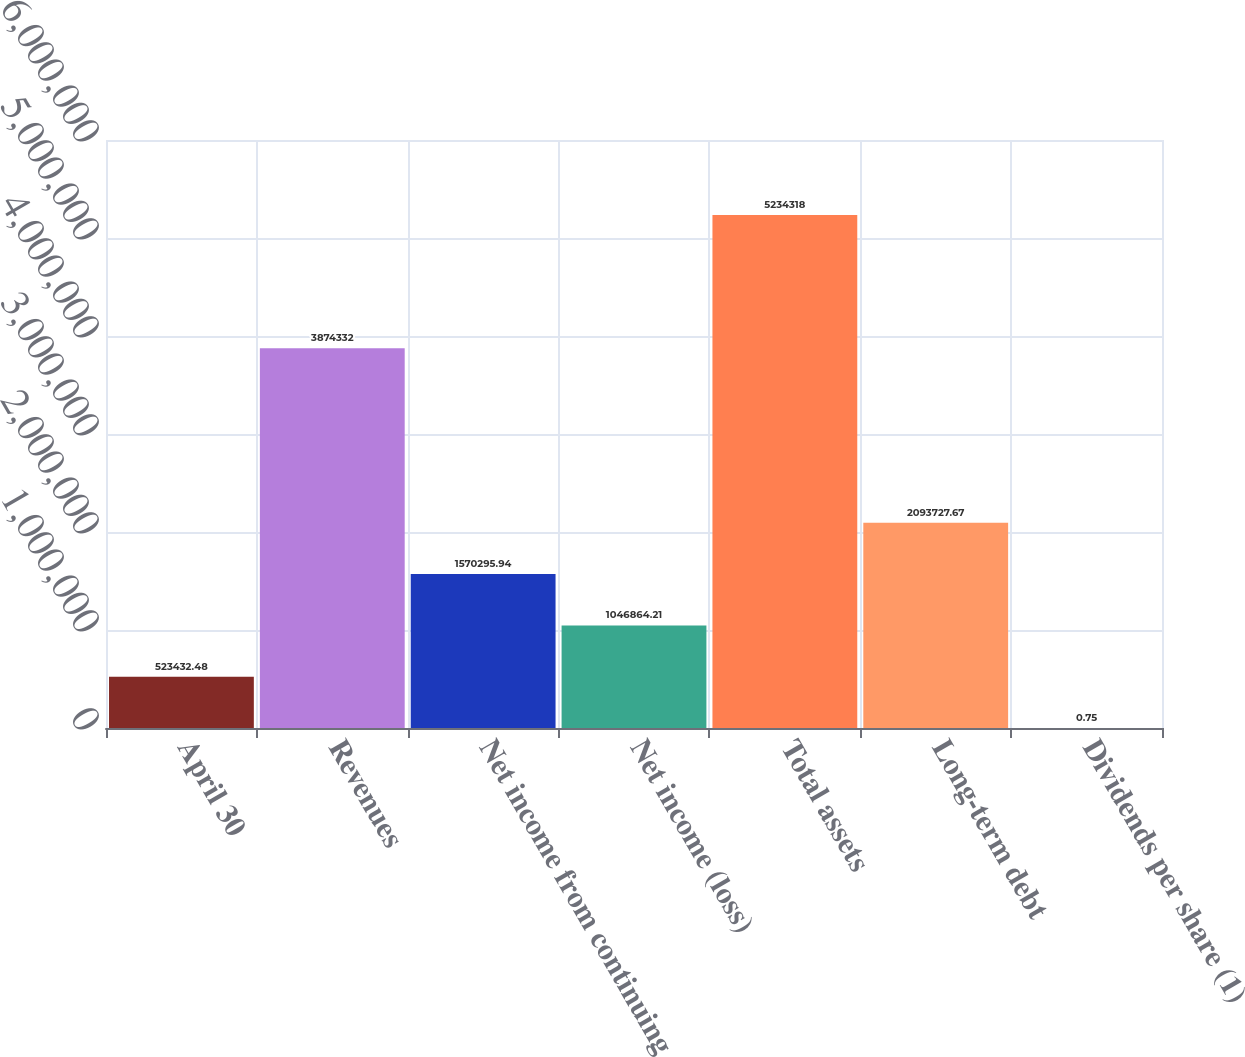Convert chart. <chart><loc_0><loc_0><loc_500><loc_500><bar_chart><fcel>April 30<fcel>Revenues<fcel>Net income from continuing<fcel>Net income (loss)<fcel>Total assets<fcel>Long-term debt<fcel>Dividends per share (1)<nl><fcel>523432<fcel>3.87433e+06<fcel>1.5703e+06<fcel>1.04686e+06<fcel>5.23432e+06<fcel>2.09373e+06<fcel>0.75<nl></chart> 